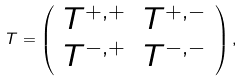Convert formula to latex. <formula><loc_0><loc_0><loc_500><loc_500>T = \left ( \begin{array} { c c } T ^ { + , + } & T ^ { + , - } \\ T ^ { - , + } & T ^ { - , - } \end{array} \right ) ,</formula> 